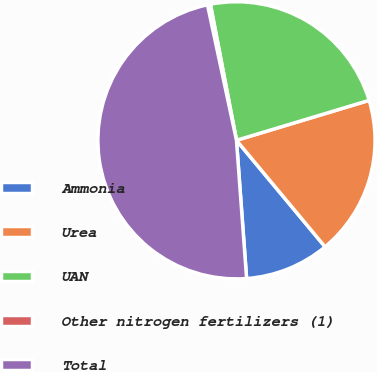<chart> <loc_0><loc_0><loc_500><loc_500><pie_chart><fcel>Ammonia<fcel>Urea<fcel>UAN<fcel>Other nitrogen fertilizers (1)<fcel>Total<nl><fcel>9.88%<fcel>18.61%<fcel>23.36%<fcel>0.34%<fcel>47.81%<nl></chart> 